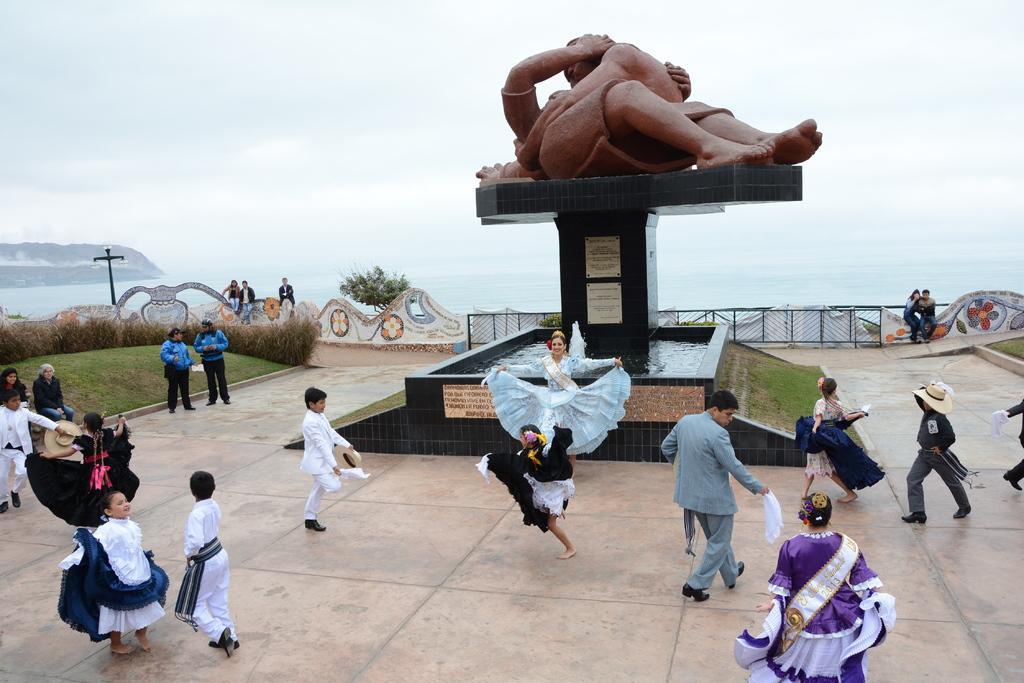Describe this image in one or two sentences. In this image, we can see a statue on an object. We can see the ground. We can see a few people. There are some posters with text. We can see some grass, plants. We can see the fence and a pole. We can see some water and hills. We can also see the sky. 